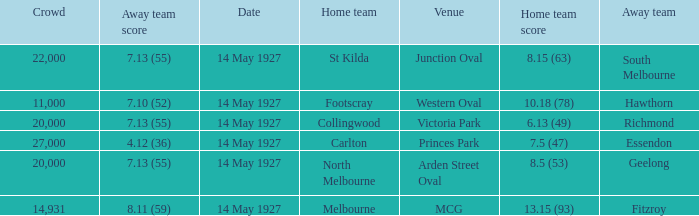How much is the sum of every crowd in attendance when the away score was 7.13 (55) for Richmond? 20000.0. 